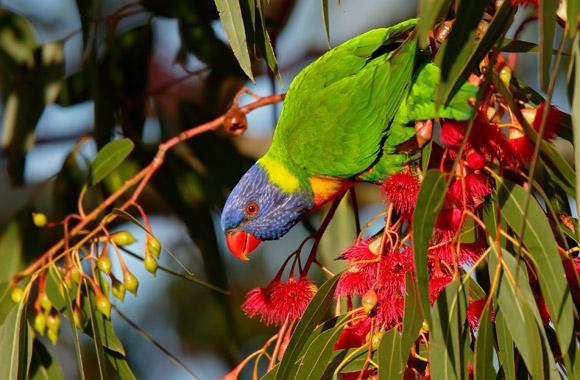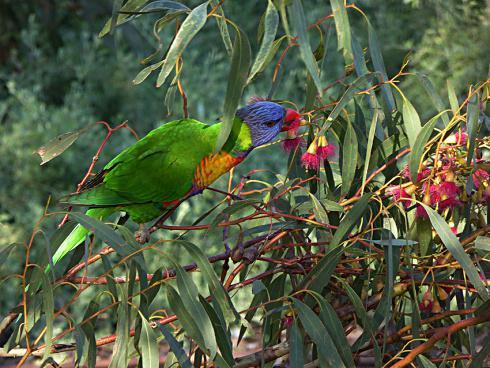The first image is the image on the left, the second image is the image on the right. For the images displayed, is the sentence "Both pictures have an identical number of parrots perched on branches in the foreground." factually correct? Answer yes or no. Yes. 